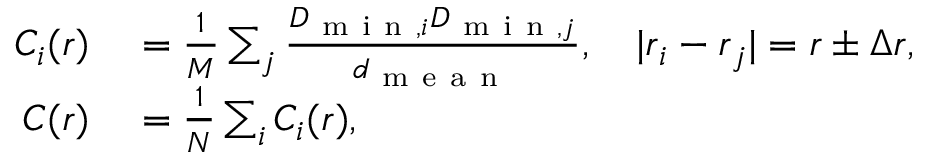Convert formula to latex. <formula><loc_0><loc_0><loc_500><loc_500>\begin{array} { r l } { C _ { i } ( r ) } & = \frac { 1 } { M } \sum _ { j } \frac { D _ { m i n , i } D _ { m i n , j } } { d _ { m e a n } } , \quad | r _ { i } - r _ { j } | = r \pm \Delta r , } \\ { C ( r ) } & = \frac { 1 } { N } \sum _ { i } C _ { i } ( r ) , } \end{array}</formula> 